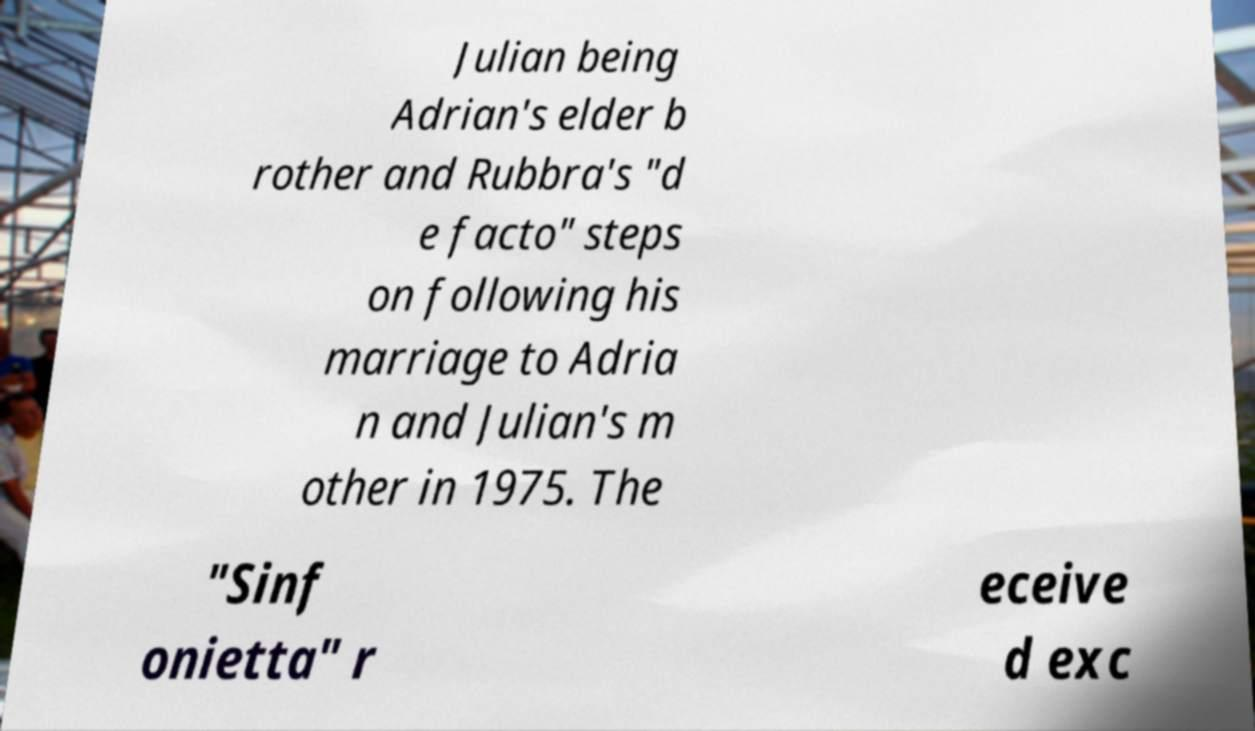Could you extract and type out the text from this image? Julian being Adrian's elder b rother and Rubbra's "d e facto" steps on following his marriage to Adria n and Julian's m other in 1975. The "Sinf onietta" r eceive d exc 